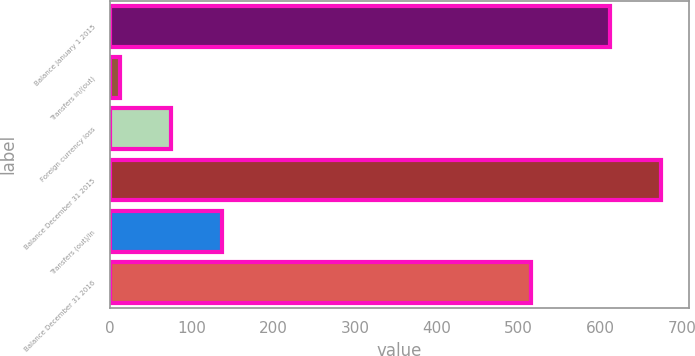Convert chart to OTSL. <chart><loc_0><loc_0><loc_500><loc_500><bar_chart><fcel>Balance January 1 2015<fcel>Transfers in/(out)<fcel>Foreign currency loss<fcel>Balance December 31 2015<fcel>Transfers (out)/in<fcel>Balance December 31 2016<nl><fcel>612<fcel>13<fcel>75.2<fcel>674.2<fcel>137.4<fcel>515<nl></chart> 